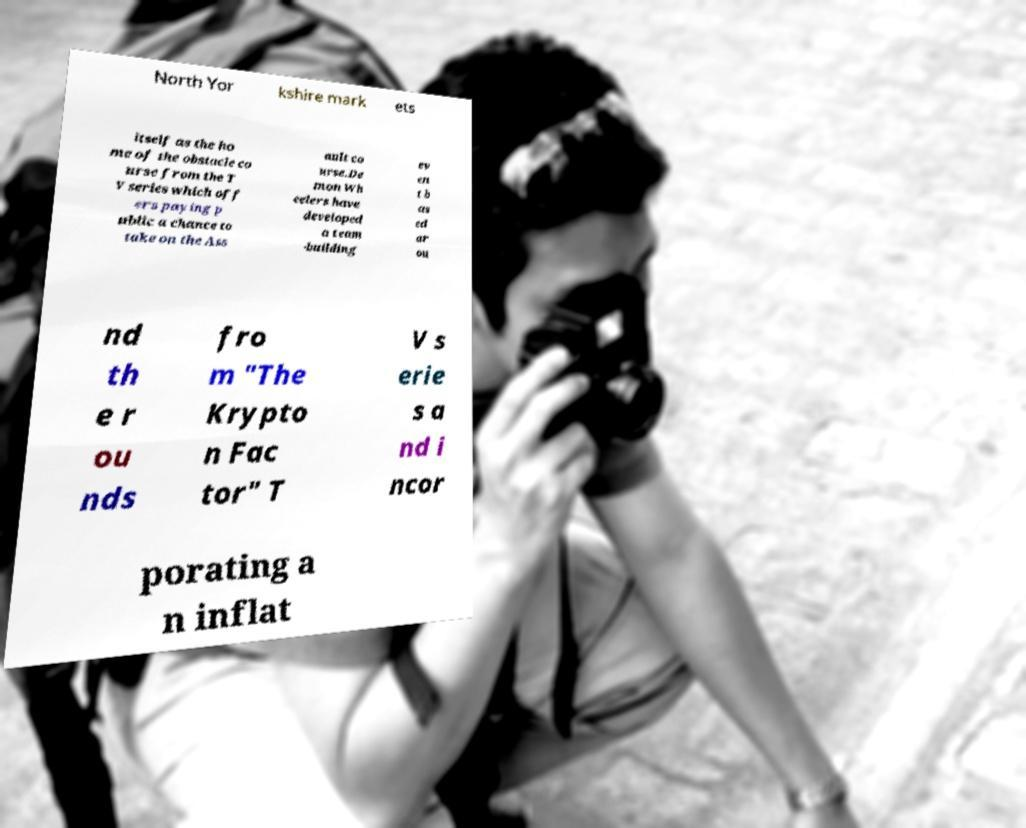Please identify and transcribe the text found in this image. North Yor kshire mark ets itself as the ho me of the obstacle co urse from the T V series which off ers paying p ublic a chance to take on the Ass ault co urse.De mon Wh eelers have developed a team -building ev en t b as ed ar ou nd th e r ou nds fro m "The Krypto n Fac tor" T V s erie s a nd i ncor porating a n inflat 